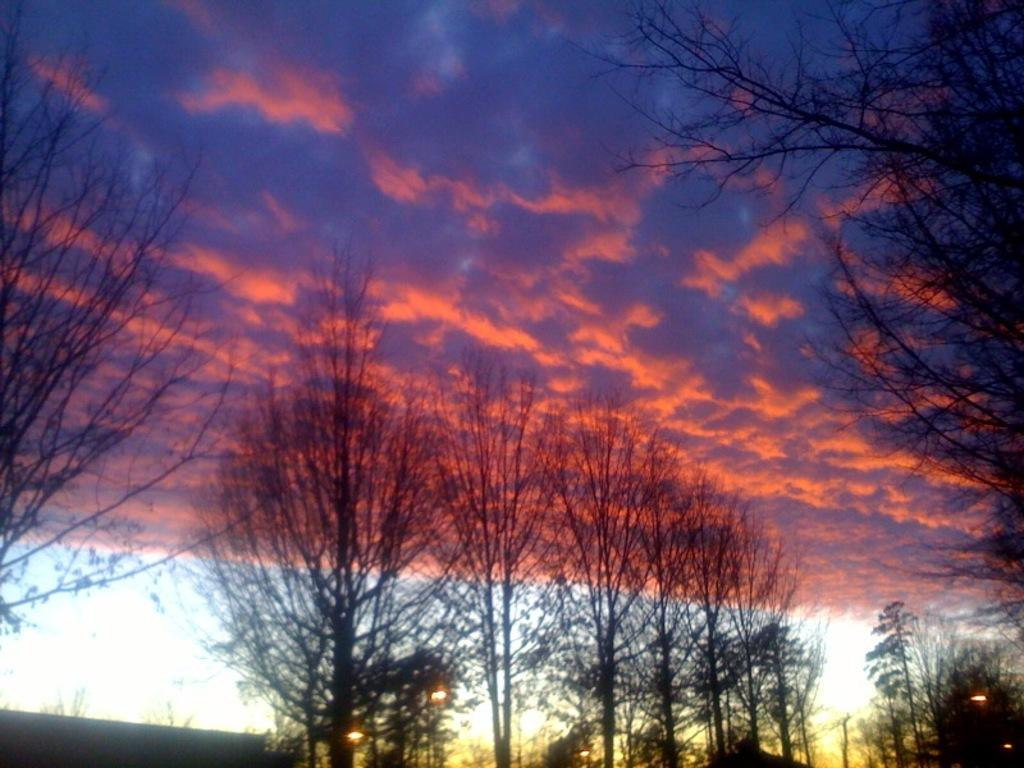What type of vegetation is present at the bottom of the image? There are trees at the bottom of the image. What part of the natural environment is visible in the image? The sky is visible in the background of the image. Can you describe the condition of the sky in the image? The sky appears to be cloudy in the image. What type of soup is being served in the office setting in the image? There is no soup or office setting present in the image; it features trees and a cloudy sky. How does the person push the tree in the image? There is no person or tree being pushed in the image; it only shows trees and a cloudy sky. 